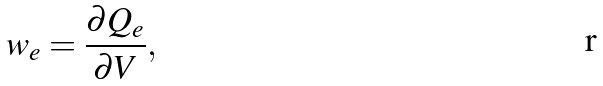Convert formula to latex. <formula><loc_0><loc_0><loc_500><loc_500>w _ { e } = { \frac { \partial Q _ { e } } { \partial V } } ,</formula> 